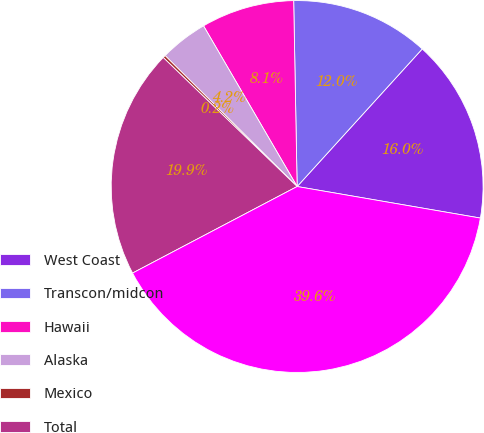Convert chart. <chart><loc_0><loc_0><loc_500><loc_500><pie_chart><fcel>West Coast<fcel>Transcon/midcon<fcel>Hawaii<fcel>Alaska<fcel>Mexico<fcel>Total<fcel>Average Stage Length<nl><fcel>15.97%<fcel>12.04%<fcel>8.1%<fcel>4.17%<fcel>0.23%<fcel>19.91%<fcel>39.58%<nl></chart> 